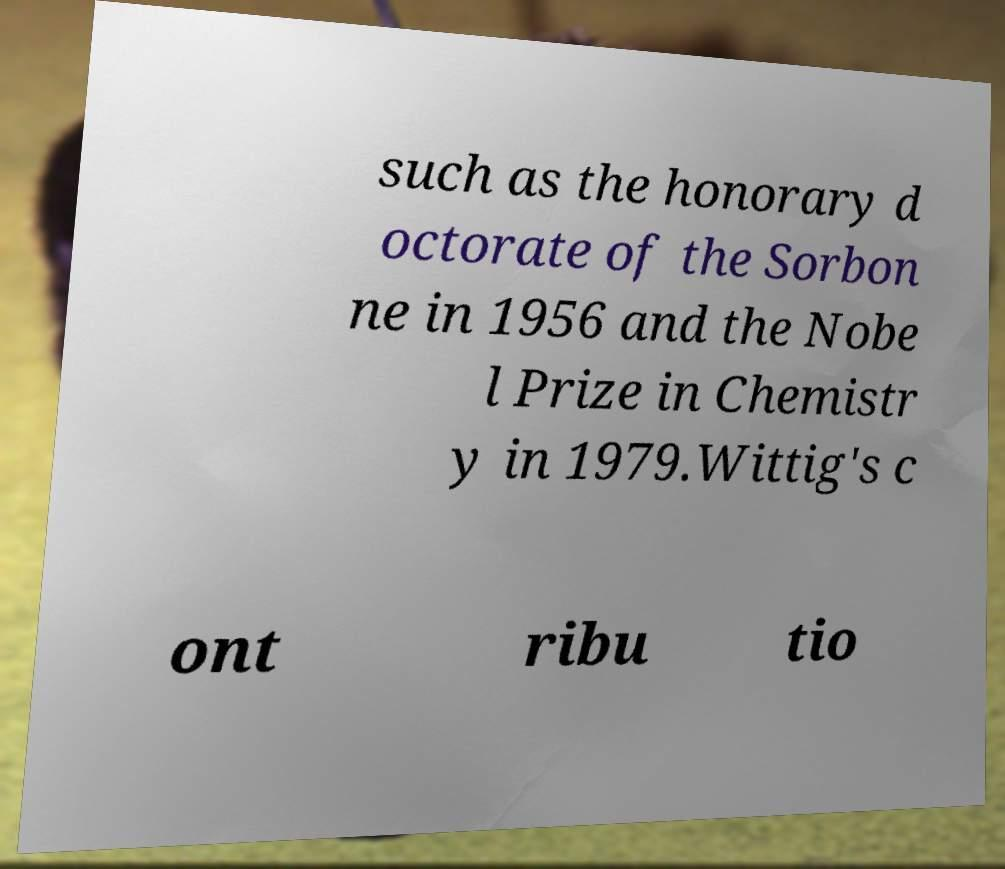Can you read and provide the text displayed in the image?This photo seems to have some interesting text. Can you extract and type it out for me? such as the honorary d octorate of the Sorbon ne in 1956 and the Nobe l Prize in Chemistr y in 1979.Wittig's c ont ribu tio 